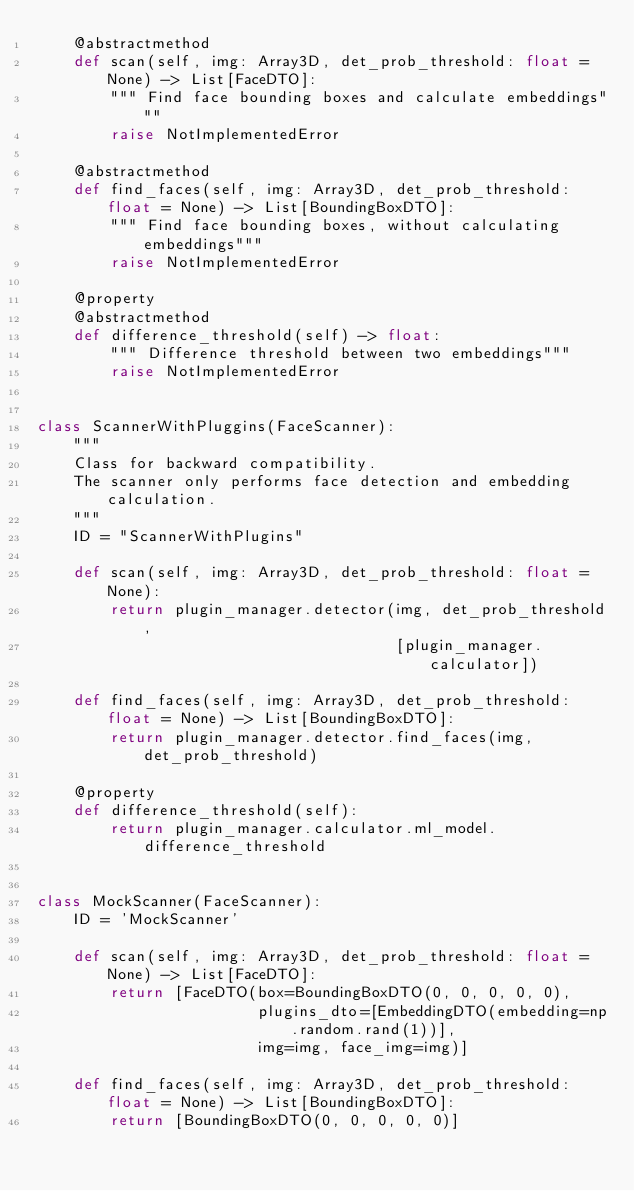<code> <loc_0><loc_0><loc_500><loc_500><_Python_>    @abstractmethod
    def scan(self, img: Array3D, det_prob_threshold: float = None) -> List[FaceDTO]:
        """ Find face bounding boxes and calculate embeddings"""
        raise NotImplementedError

    @abstractmethod
    def find_faces(self, img: Array3D, det_prob_threshold: float = None) -> List[BoundingBoxDTO]:
        """ Find face bounding boxes, without calculating embeddings"""
        raise NotImplementedError

    @property
    @abstractmethod
    def difference_threshold(self) -> float:
        """ Difference threshold between two embeddings"""
        raise NotImplementedError


class ScannerWithPluggins(FaceScanner):
    """
    Class for backward compatibility.
    The scanner only performs face detection and embedding calculation.
    """
    ID = "ScannerWithPlugins"

    def scan(self, img: Array3D, det_prob_threshold: float = None):
        return plugin_manager.detector(img, det_prob_threshold,
                                       [plugin_manager.calculator])

    def find_faces(self, img: Array3D, det_prob_threshold: float = None) -> List[BoundingBoxDTO]:
        return plugin_manager.detector.find_faces(img, det_prob_threshold)

    @property
    def difference_threshold(self):
        return plugin_manager.calculator.ml_model.difference_threshold


class MockScanner(FaceScanner):
    ID = 'MockScanner'

    def scan(self, img: Array3D, det_prob_threshold: float = None) -> List[FaceDTO]:
        return [FaceDTO(box=BoundingBoxDTO(0, 0, 0, 0, 0),
                        plugins_dto=[EmbeddingDTO(embedding=np.random.rand(1))],
                        img=img, face_img=img)]

    def find_faces(self, img: Array3D, det_prob_threshold: float = None) -> List[BoundingBoxDTO]:
        return [BoundingBoxDTO(0, 0, 0, 0, 0)]
</code> 